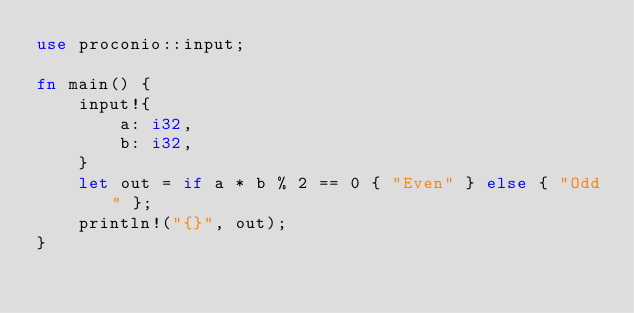<code> <loc_0><loc_0><loc_500><loc_500><_Rust_>use proconio::input;

fn main() {
    input!{
        a: i32,
        b: i32,
    }
    let out = if a * b % 2 == 0 { "Even" } else { "Odd" };
    println!("{}", out);
}
</code> 